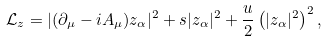<formula> <loc_0><loc_0><loc_500><loc_500>\mathcal { L } _ { z } = | ( \partial _ { \mu } - i A _ { \mu } ) z _ { \alpha } | ^ { 2 } + s | z _ { \alpha } | ^ { 2 } + \frac { u } { 2 } \left ( | z _ { \alpha } | ^ { 2 } \right ) ^ { 2 } ,</formula> 